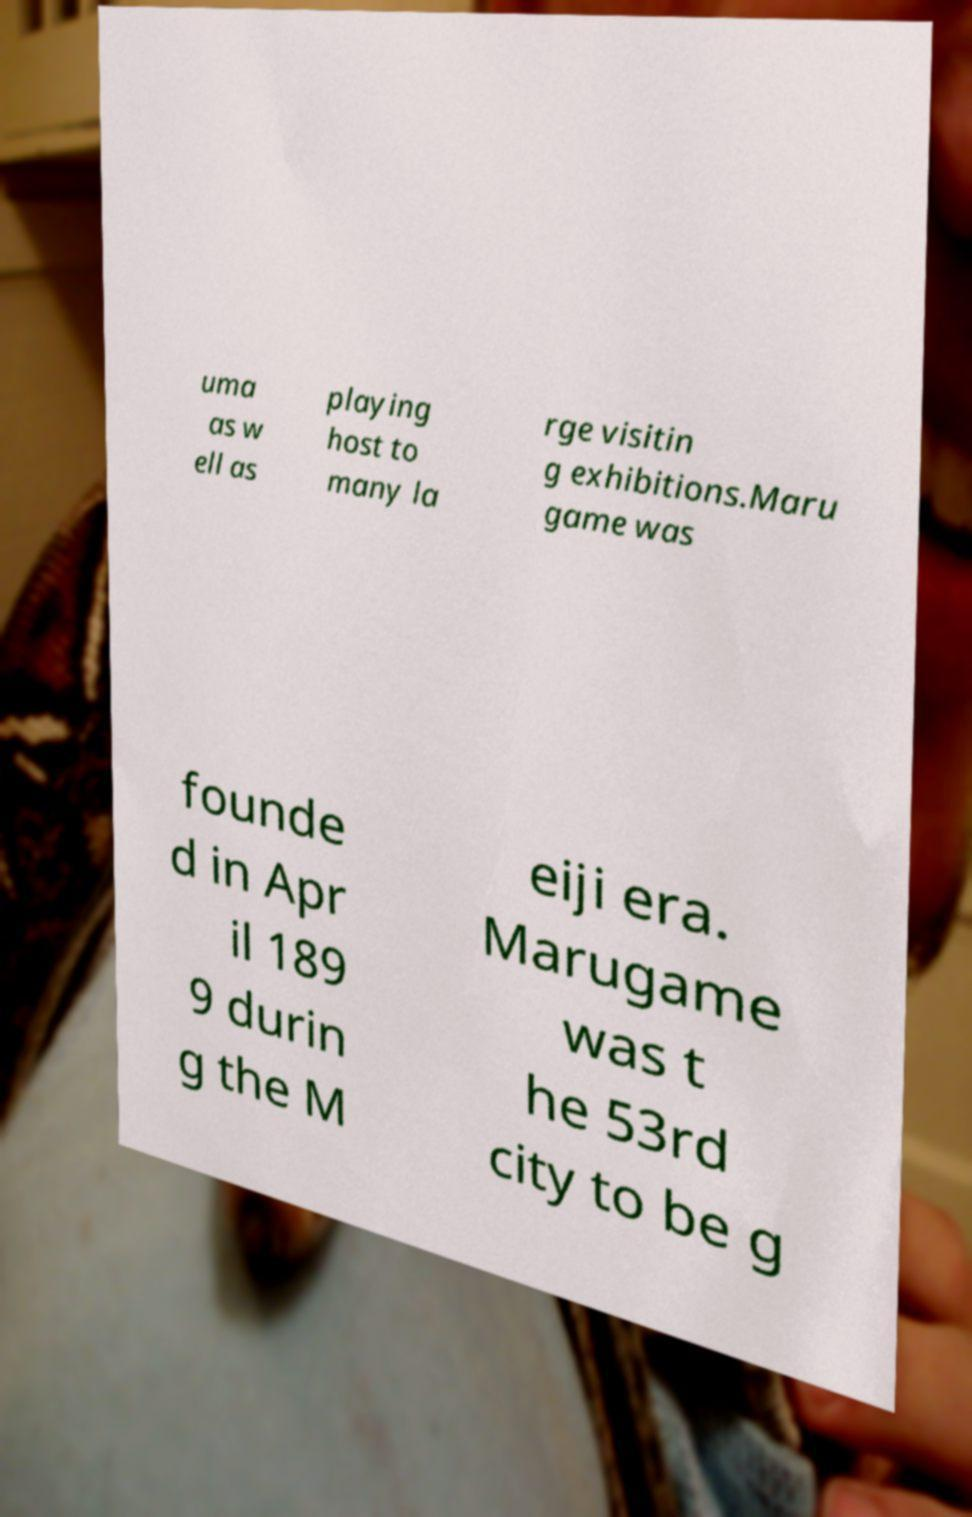Could you assist in decoding the text presented in this image and type it out clearly? uma as w ell as playing host to many la rge visitin g exhibitions.Maru game was founde d in Apr il 189 9 durin g the M eiji era. Marugame was t he 53rd city to be g 